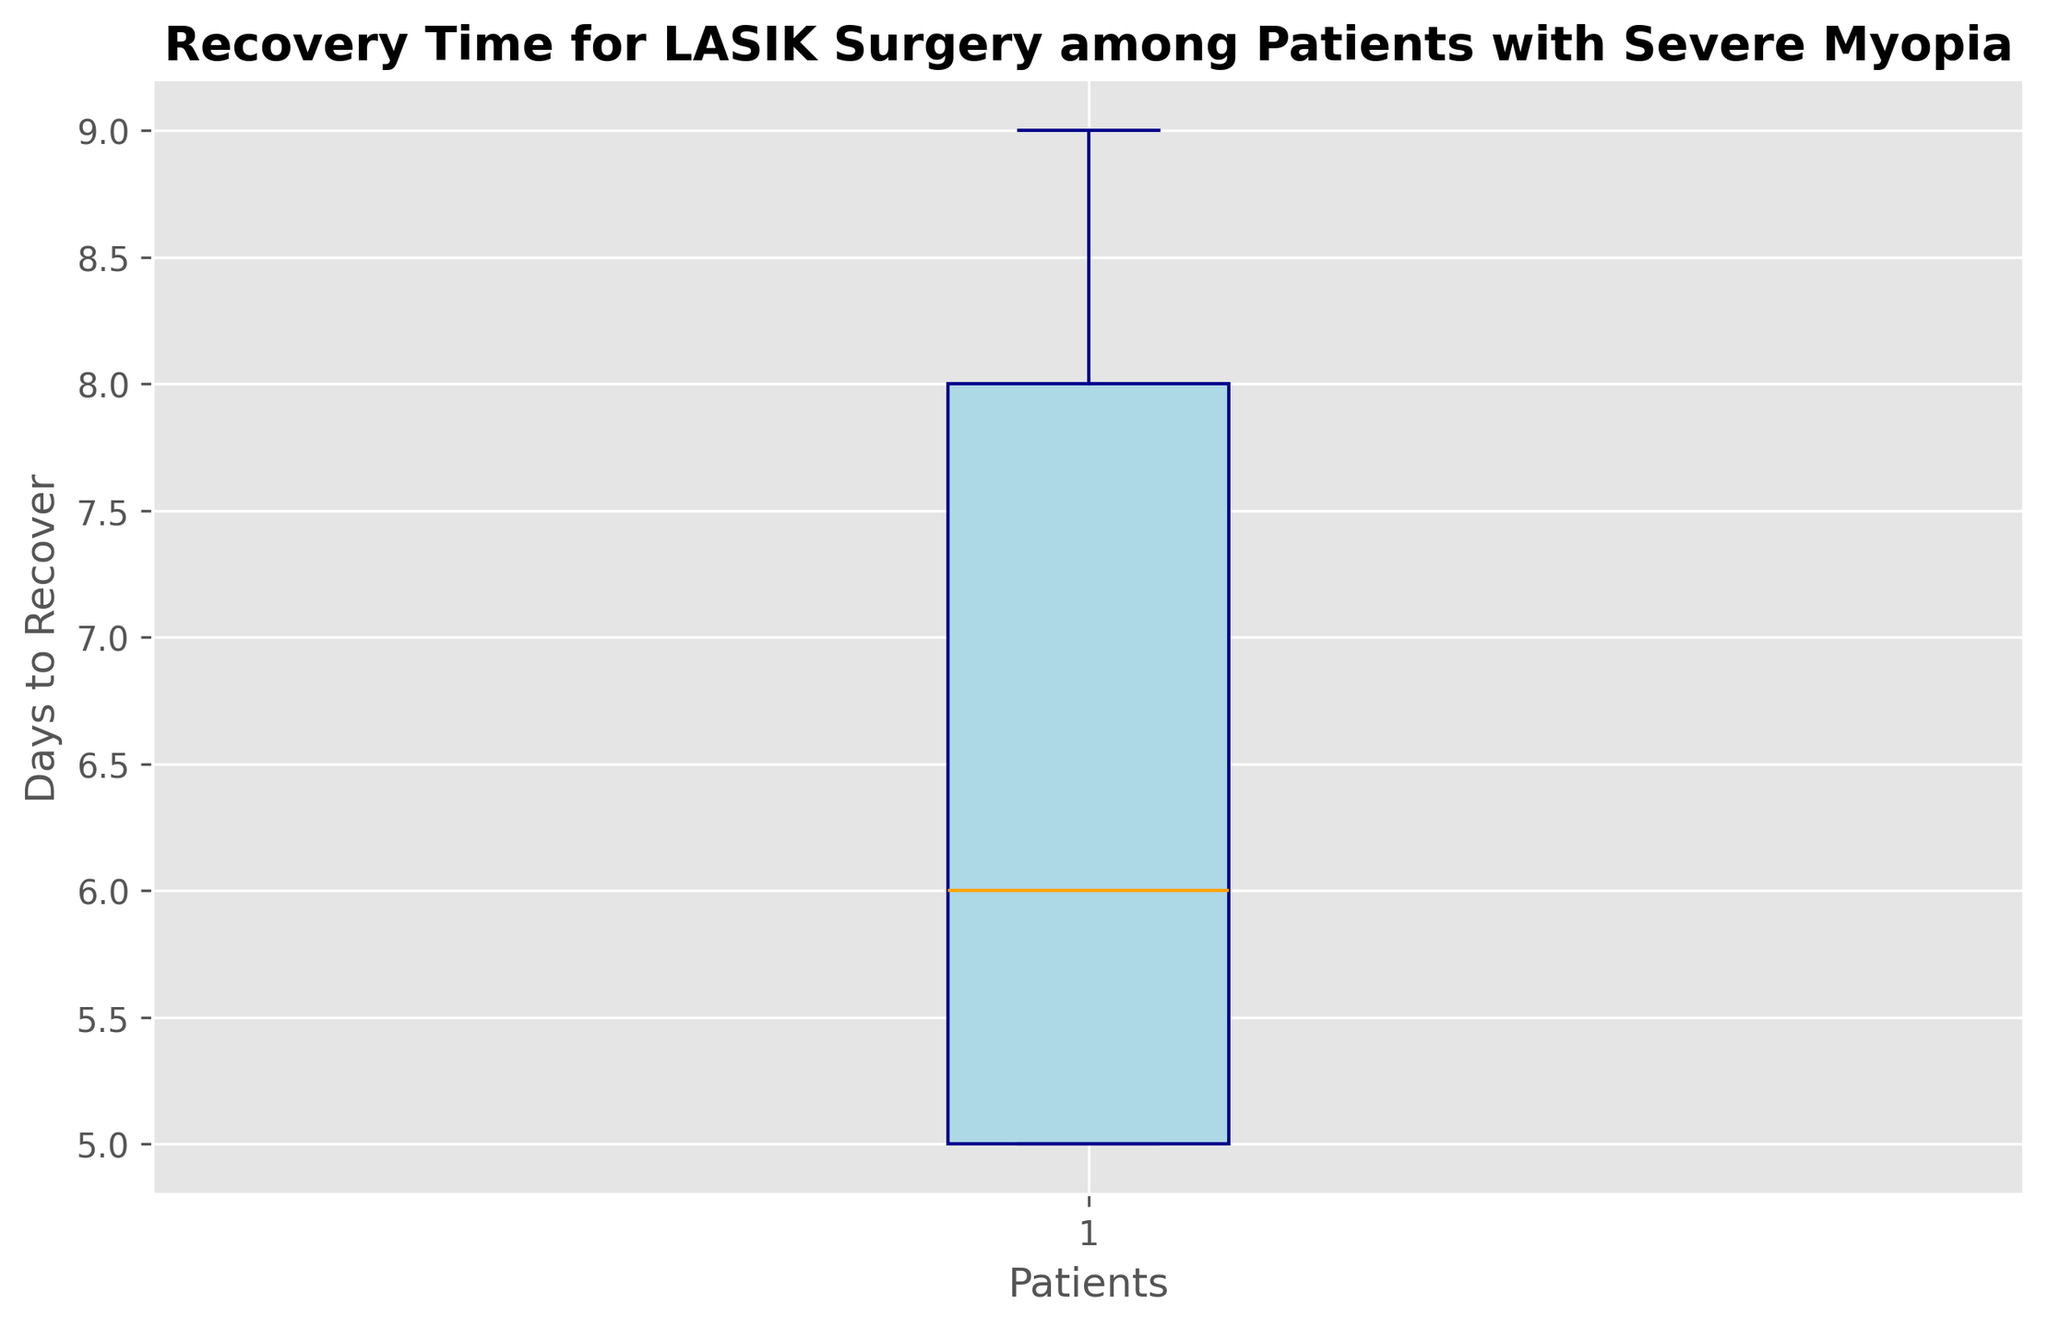What is the median recovery time for LASIK surgery among patients with severe myopia? The box plot has a line inside the box that represents the median. By inspecting the plot, we can determine where this line is located along the y-axis.
Answer: 6 days What is the range of recovery times shown in the box plot? The range is determined by calculating the difference between the maximum and minimum values, which are indicated by the whiskers of the box plot.
Answer: 4-9 days Which visual element shows the most common recovery time and what value does it represent? The median line inside the box is the most common measure, showing central tendency. Inspecting this line tells us the most common recovery time.
Answer: 6 days Compare the highest and the lowest recovery times. What is the difference? The highest recovery time is at the top whisker, and the lowest recovery time is at the bottom whisker. Subtraction of these two values gives the difference.
Answer: 5 days What is the interquartile range (IQR) of the recovery times? The IQR is found by calculating the difference between the upper quartile (Q3, which is the top of the box) and the lower quartile (Q1, which is the bottom of the box).
Answer: 2 days Are there any outliers in the recovery times, and how are they visually represented? Outliers are usually represented by points outside the whiskers. Inspecting the plot for any such points will reveal outliers.
Answer: No significant outliers Which recovery time is the most frequent, and how is it visually represented on the box plot? The most frequent recovery time corresponds to the location of the median line inside the box. This line's position on the y-axis shows the most frequent recovery time.
Answer: 6 days Is the recovery time distribution symmetric or skewed? By inspecting the length of the whiskers and the placement of the median within the box, we can determine whether the distribution is symmetric (even whiskers and median in the center) or skewed (uneven whiskers or off-center median).
Answer: Slightly skewed What is the lower quartile (Q1) of the recovery times? The lower quartile (Q1) is at the bottom of the box. We look at where this bottom line of the box falls on the y-axis to find Q1.
Answer: 5 days What does the middle 50% of the recovery times indicate? The middle 50% is indicated by the box itself, bounded by Q1 (the lower quartile) and Q3 (the upper quartile). This shows where the central 50% of the data lies.
Answer: 5-7 days 